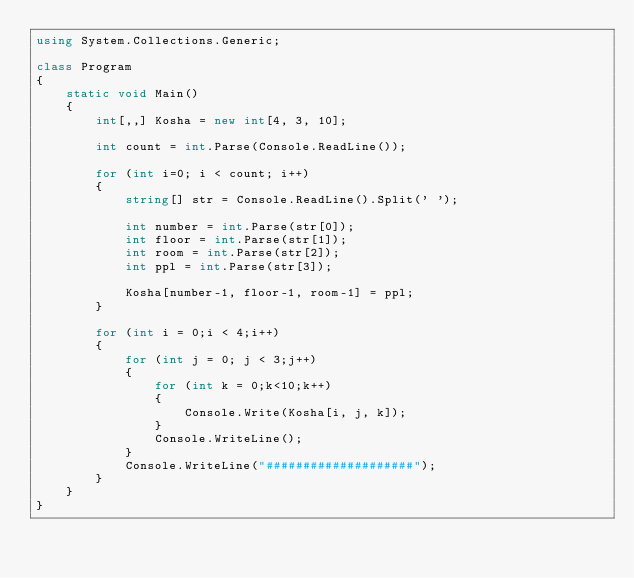<code> <loc_0><loc_0><loc_500><loc_500><_C#_>using System.Collections.Generic;

class Program
{
    static void Main()
    {
        int[,,] Kosha = new int[4, 3, 10];

        int count = int.Parse(Console.ReadLine());

        for (int i=0; i < count; i++)
        {
            string[] str = Console.ReadLine().Split(' ');

            int number = int.Parse(str[0]);
            int floor = int.Parse(str[1]);
            int room = int.Parse(str[2]);
            int ppl = int.Parse(str[3]);

            Kosha[number-1, floor-1, room-1] = ppl;
        }

        for (int i = 0;i < 4;i++)
        {
            for (int j = 0; j < 3;j++)
            {
                for (int k = 0;k<10;k++)
                {
                    Console.Write(Kosha[i, j, k]);
                }
                Console.WriteLine();
            }
            Console.WriteLine("####################");
        }
    }
}</code> 